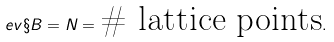<formula> <loc_0><loc_0><loc_500><loc_500>\ e v { \S B } = N = \text {\# lattice points} .</formula> 